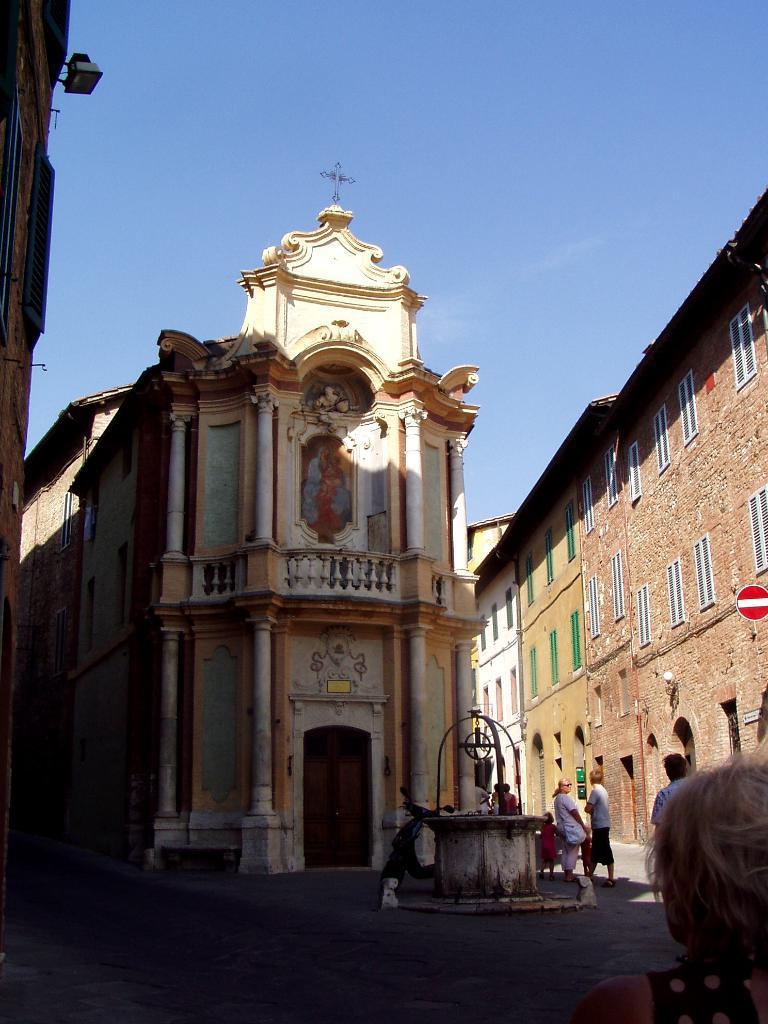How would you summarize this image in a sentence or two? Here we can see buildings, people, motorbike and well. To these buildings there are windows and doors. Sky is in blue color. This is a signboard.  